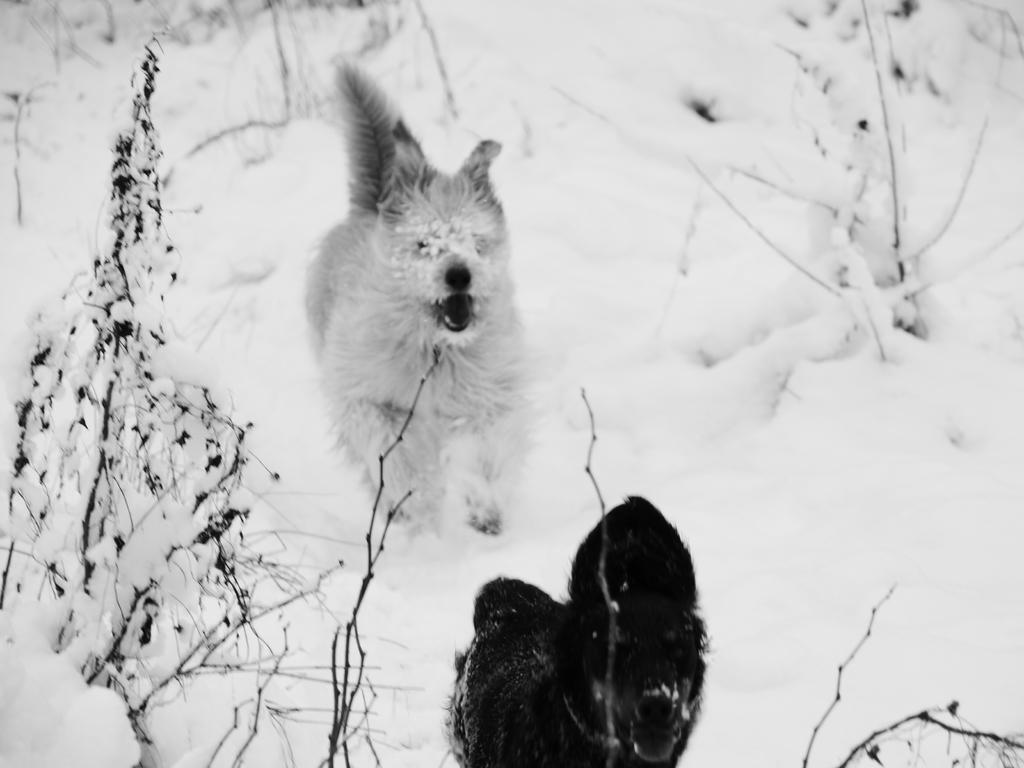How would you summarize this image in a sentence or two? In this image we can see two dogs in the snow. 